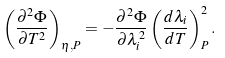Convert formula to latex. <formula><loc_0><loc_0><loc_500><loc_500>\left ( \frac { \partial ^ { 2 } \Phi } { \partial T ^ { 2 } } \right ) _ { \eta , P } = - \frac { \partial ^ { 2 } \Phi } { \partial \lambda _ { i } ^ { 2 } } \left ( \frac { d \lambda _ { i } } { d T } \right ) _ { P } ^ { 2 } .</formula> 